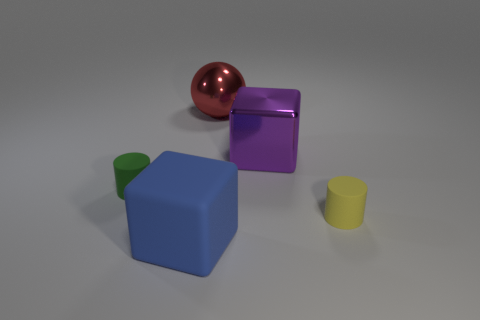What shape is the shiny object right of the large metallic object that is behind the large purple block?
Make the answer very short. Cube. Does the blue cube have the same size as the cylinder to the right of the small green cylinder?
Make the answer very short. No. There is a block behind the yellow matte object; what material is it?
Your response must be concise. Metal. What number of things are in front of the large purple metal thing and behind the large purple thing?
Your answer should be compact. 0. There is a red ball that is the same size as the matte cube; what material is it?
Your response must be concise. Metal. There is a object right of the purple shiny block; is it the same size as the rubber object to the left of the large blue cube?
Ensure brevity in your answer.  Yes. There is a red ball; are there any shiny things in front of it?
Offer a terse response. Yes. There is a cylinder that is in front of the cylinder on the left side of the yellow thing; what is its color?
Offer a very short reply. Yellow. Is the number of purple cubes less than the number of objects?
Provide a succinct answer. Yes. What number of large blue rubber objects have the same shape as the red metal object?
Provide a short and direct response. 0. 